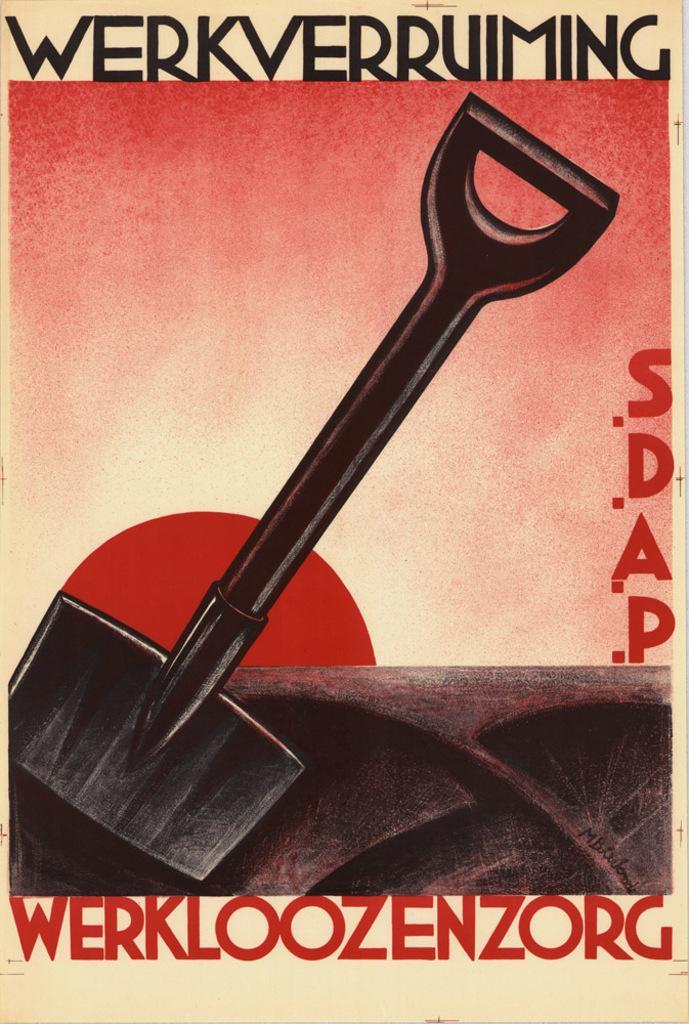In one or two sentences, can you explain what this image depicts? In this image we can see a poster with text and image. 